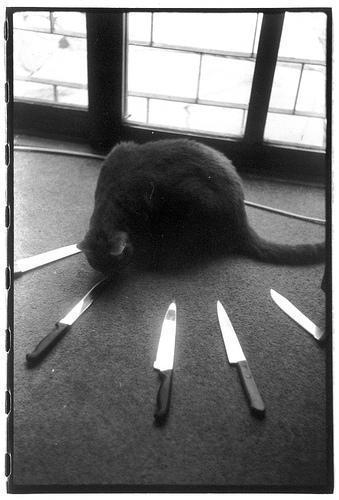What is surrounding the cat?
Indicate the correct response and explain using: 'Answer: answer
Rationale: rationale.'
Options: Knives, dogs, penguins, foxes. Answer: knives.
Rationale: There are five objects surrounding the cat. What is the cat near?
Choose the correct response and explain in the format: 'Answer: answer
Rationale: rationale.'
Options: Knives, spoons, boxes, apples. Answer: knives.
Rationale: The kitty is on the floor with many cutting tools around him. 